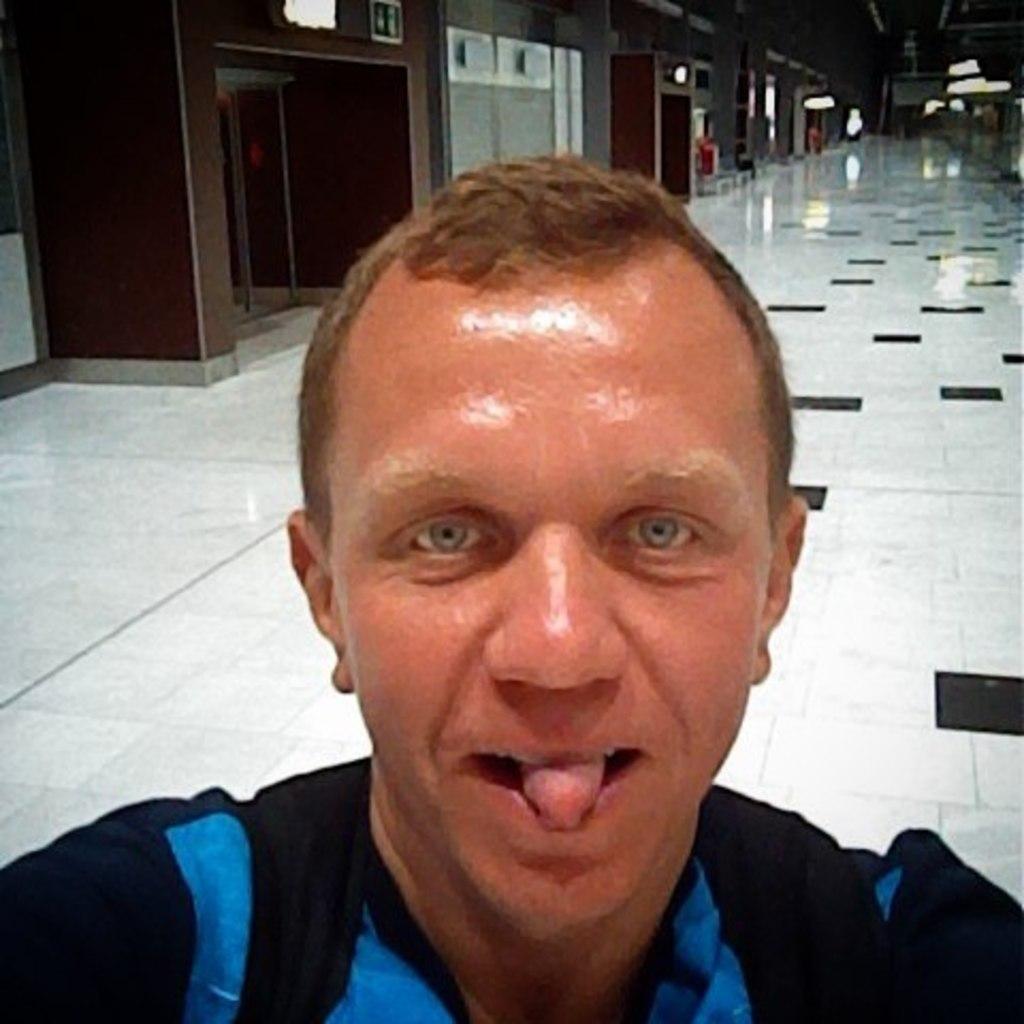Describe this image in one or two sentences. In this image we can see a man. In the background there are doors, walls and lights. 